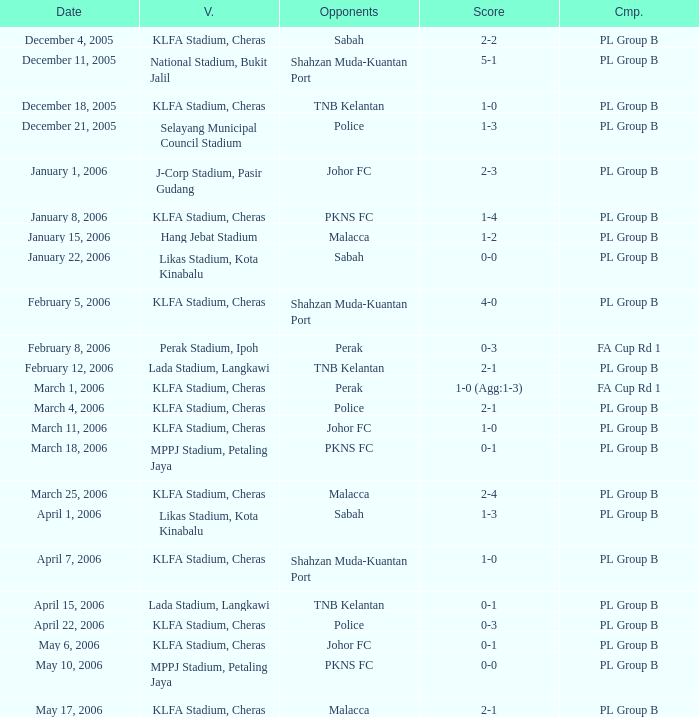Which Competition has Opponents of pkns fc, and a Score of 0-0? PL Group B. 